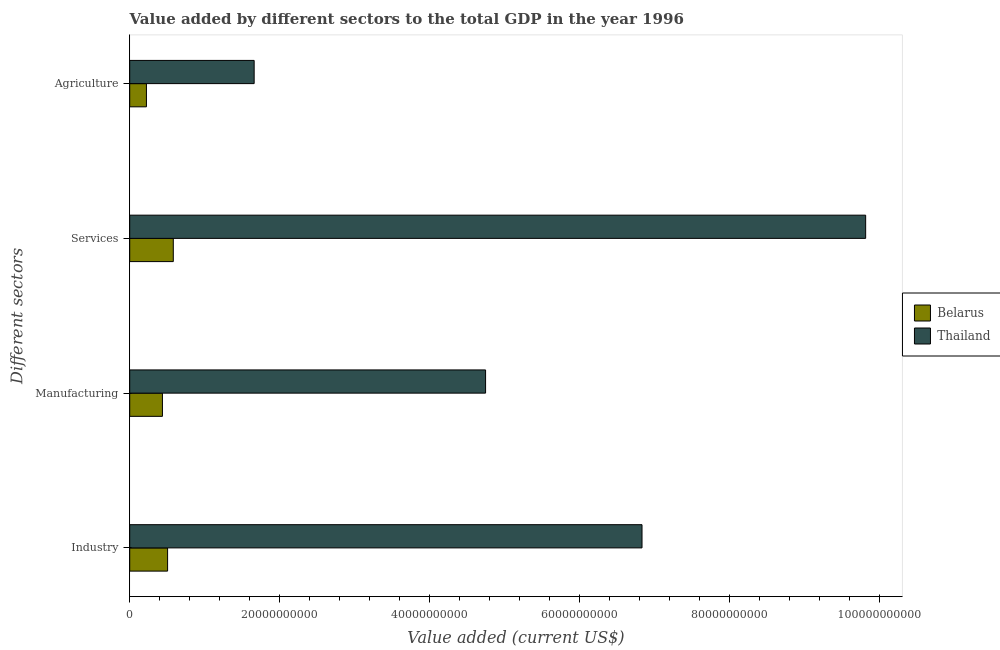Are the number of bars per tick equal to the number of legend labels?
Provide a succinct answer. Yes. Are the number of bars on each tick of the Y-axis equal?
Ensure brevity in your answer.  Yes. What is the label of the 3rd group of bars from the top?
Offer a terse response. Manufacturing. What is the value added by services sector in Belarus?
Provide a succinct answer. 5.81e+09. Across all countries, what is the maximum value added by manufacturing sector?
Your response must be concise. 4.75e+1. Across all countries, what is the minimum value added by agricultural sector?
Your response must be concise. 2.23e+09. In which country was the value added by industrial sector maximum?
Offer a terse response. Thailand. In which country was the value added by agricultural sector minimum?
Offer a terse response. Belarus. What is the total value added by manufacturing sector in the graph?
Your answer should be very brief. 5.18e+1. What is the difference between the value added by services sector in Thailand and that in Belarus?
Provide a short and direct response. 9.23e+1. What is the difference between the value added by manufacturing sector in Belarus and the value added by agricultural sector in Thailand?
Provide a succinct answer. -1.22e+1. What is the average value added by services sector per country?
Provide a short and direct response. 5.20e+1. What is the difference between the value added by services sector and value added by industrial sector in Thailand?
Offer a very short reply. 2.98e+1. In how many countries, is the value added by services sector greater than 28000000000 US$?
Keep it short and to the point. 1. What is the ratio of the value added by services sector in Belarus to that in Thailand?
Give a very brief answer. 0.06. Is the difference between the value added by industrial sector in Belarus and Thailand greater than the difference between the value added by manufacturing sector in Belarus and Thailand?
Offer a terse response. No. What is the difference between the highest and the second highest value added by manufacturing sector?
Your answer should be compact. 4.31e+1. What is the difference between the highest and the lowest value added by industrial sector?
Make the answer very short. 6.33e+1. What does the 2nd bar from the top in Manufacturing represents?
Ensure brevity in your answer.  Belarus. What does the 2nd bar from the bottom in Agriculture represents?
Make the answer very short. Thailand. Are all the bars in the graph horizontal?
Your answer should be compact. Yes. How many countries are there in the graph?
Make the answer very short. 2. What is the difference between two consecutive major ticks on the X-axis?
Make the answer very short. 2.00e+1. Does the graph contain grids?
Give a very brief answer. No. What is the title of the graph?
Provide a short and direct response. Value added by different sectors to the total GDP in the year 1996. What is the label or title of the X-axis?
Your answer should be very brief. Value added (current US$). What is the label or title of the Y-axis?
Your response must be concise. Different sectors. What is the Value added (current US$) of Belarus in Industry?
Your answer should be very brief. 5.05e+09. What is the Value added (current US$) of Thailand in Industry?
Your answer should be very brief. 6.83e+1. What is the Value added (current US$) in Belarus in Manufacturing?
Offer a very short reply. 4.36e+09. What is the Value added (current US$) in Thailand in Manufacturing?
Provide a short and direct response. 4.75e+1. What is the Value added (current US$) of Belarus in Services?
Provide a succinct answer. 5.81e+09. What is the Value added (current US$) of Thailand in Services?
Offer a very short reply. 9.81e+1. What is the Value added (current US$) of Belarus in Agriculture?
Your answer should be compact. 2.23e+09. What is the Value added (current US$) in Thailand in Agriculture?
Your answer should be compact. 1.66e+1. Across all Different sectors, what is the maximum Value added (current US$) of Belarus?
Your response must be concise. 5.81e+09. Across all Different sectors, what is the maximum Value added (current US$) of Thailand?
Provide a short and direct response. 9.81e+1. Across all Different sectors, what is the minimum Value added (current US$) in Belarus?
Provide a succinct answer. 2.23e+09. Across all Different sectors, what is the minimum Value added (current US$) of Thailand?
Keep it short and to the point. 1.66e+1. What is the total Value added (current US$) in Belarus in the graph?
Keep it short and to the point. 1.74e+1. What is the total Value added (current US$) of Thailand in the graph?
Ensure brevity in your answer.  2.30e+11. What is the difference between the Value added (current US$) in Belarus in Industry and that in Manufacturing?
Your answer should be very brief. 6.88e+08. What is the difference between the Value added (current US$) of Thailand in Industry and that in Manufacturing?
Offer a very short reply. 2.09e+1. What is the difference between the Value added (current US$) of Belarus in Industry and that in Services?
Offer a terse response. -7.59e+08. What is the difference between the Value added (current US$) in Thailand in Industry and that in Services?
Keep it short and to the point. -2.98e+1. What is the difference between the Value added (current US$) in Belarus in Industry and that in Agriculture?
Your answer should be compact. 2.82e+09. What is the difference between the Value added (current US$) in Thailand in Industry and that in Agriculture?
Offer a terse response. 5.17e+1. What is the difference between the Value added (current US$) in Belarus in Manufacturing and that in Services?
Make the answer very short. -1.45e+09. What is the difference between the Value added (current US$) of Thailand in Manufacturing and that in Services?
Offer a very short reply. -5.07e+1. What is the difference between the Value added (current US$) in Belarus in Manufacturing and that in Agriculture?
Your answer should be compact. 2.13e+09. What is the difference between the Value added (current US$) of Thailand in Manufacturing and that in Agriculture?
Your answer should be very brief. 3.09e+1. What is the difference between the Value added (current US$) of Belarus in Services and that in Agriculture?
Make the answer very short. 3.58e+09. What is the difference between the Value added (current US$) in Thailand in Services and that in Agriculture?
Your response must be concise. 8.15e+1. What is the difference between the Value added (current US$) of Belarus in Industry and the Value added (current US$) of Thailand in Manufacturing?
Provide a succinct answer. -4.24e+1. What is the difference between the Value added (current US$) in Belarus in Industry and the Value added (current US$) in Thailand in Services?
Offer a very short reply. -9.31e+1. What is the difference between the Value added (current US$) in Belarus in Industry and the Value added (current US$) in Thailand in Agriculture?
Keep it short and to the point. -1.15e+1. What is the difference between the Value added (current US$) of Belarus in Manufacturing and the Value added (current US$) of Thailand in Services?
Keep it short and to the point. -9.38e+1. What is the difference between the Value added (current US$) of Belarus in Manufacturing and the Value added (current US$) of Thailand in Agriculture?
Ensure brevity in your answer.  -1.22e+1. What is the difference between the Value added (current US$) in Belarus in Services and the Value added (current US$) in Thailand in Agriculture?
Your answer should be very brief. -1.08e+1. What is the average Value added (current US$) in Belarus per Different sectors?
Offer a very short reply. 4.36e+09. What is the average Value added (current US$) in Thailand per Different sectors?
Your answer should be very brief. 5.76e+1. What is the difference between the Value added (current US$) of Belarus and Value added (current US$) of Thailand in Industry?
Make the answer very short. -6.33e+1. What is the difference between the Value added (current US$) in Belarus and Value added (current US$) in Thailand in Manufacturing?
Ensure brevity in your answer.  -4.31e+1. What is the difference between the Value added (current US$) of Belarus and Value added (current US$) of Thailand in Services?
Your answer should be very brief. -9.23e+1. What is the difference between the Value added (current US$) in Belarus and Value added (current US$) in Thailand in Agriculture?
Make the answer very short. -1.44e+1. What is the ratio of the Value added (current US$) of Belarus in Industry to that in Manufacturing?
Keep it short and to the point. 1.16. What is the ratio of the Value added (current US$) of Thailand in Industry to that in Manufacturing?
Ensure brevity in your answer.  1.44. What is the ratio of the Value added (current US$) of Belarus in Industry to that in Services?
Provide a succinct answer. 0.87. What is the ratio of the Value added (current US$) in Thailand in Industry to that in Services?
Your answer should be very brief. 0.7. What is the ratio of the Value added (current US$) of Belarus in Industry to that in Agriculture?
Make the answer very short. 2.27. What is the ratio of the Value added (current US$) in Thailand in Industry to that in Agriculture?
Offer a terse response. 4.12. What is the ratio of the Value added (current US$) in Belarus in Manufacturing to that in Services?
Keep it short and to the point. 0.75. What is the ratio of the Value added (current US$) of Thailand in Manufacturing to that in Services?
Make the answer very short. 0.48. What is the ratio of the Value added (current US$) of Belarus in Manufacturing to that in Agriculture?
Provide a succinct answer. 1.96. What is the ratio of the Value added (current US$) in Thailand in Manufacturing to that in Agriculture?
Keep it short and to the point. 2.86. What is the ratio of the Value added (current US$) in Belarus in Services to that in Agriculture?
Provide a succinct answer. 2.61. What is the ratio of the Value added (current US$) of Thailand in Services to that in Agriculture?
Keep it short and to the point. 5.91. What is the difference between the highest and the second highest Value added (current US$) of Belarus?
Give a very brief answer. 7.59e+08. What is the difference between the highest and the second highest Value added (current US$) of Thailand?
Provide a short and direct response. 2.98e+1. What is the difference between the highest and the lowest Value added (current US$) in Belarus?
Your answer should be compact. 3.58e+09. What is the difference between the highest and the lowest Value added (current US$) in Thailand?
Offer a terse response. 8.15e+1. 